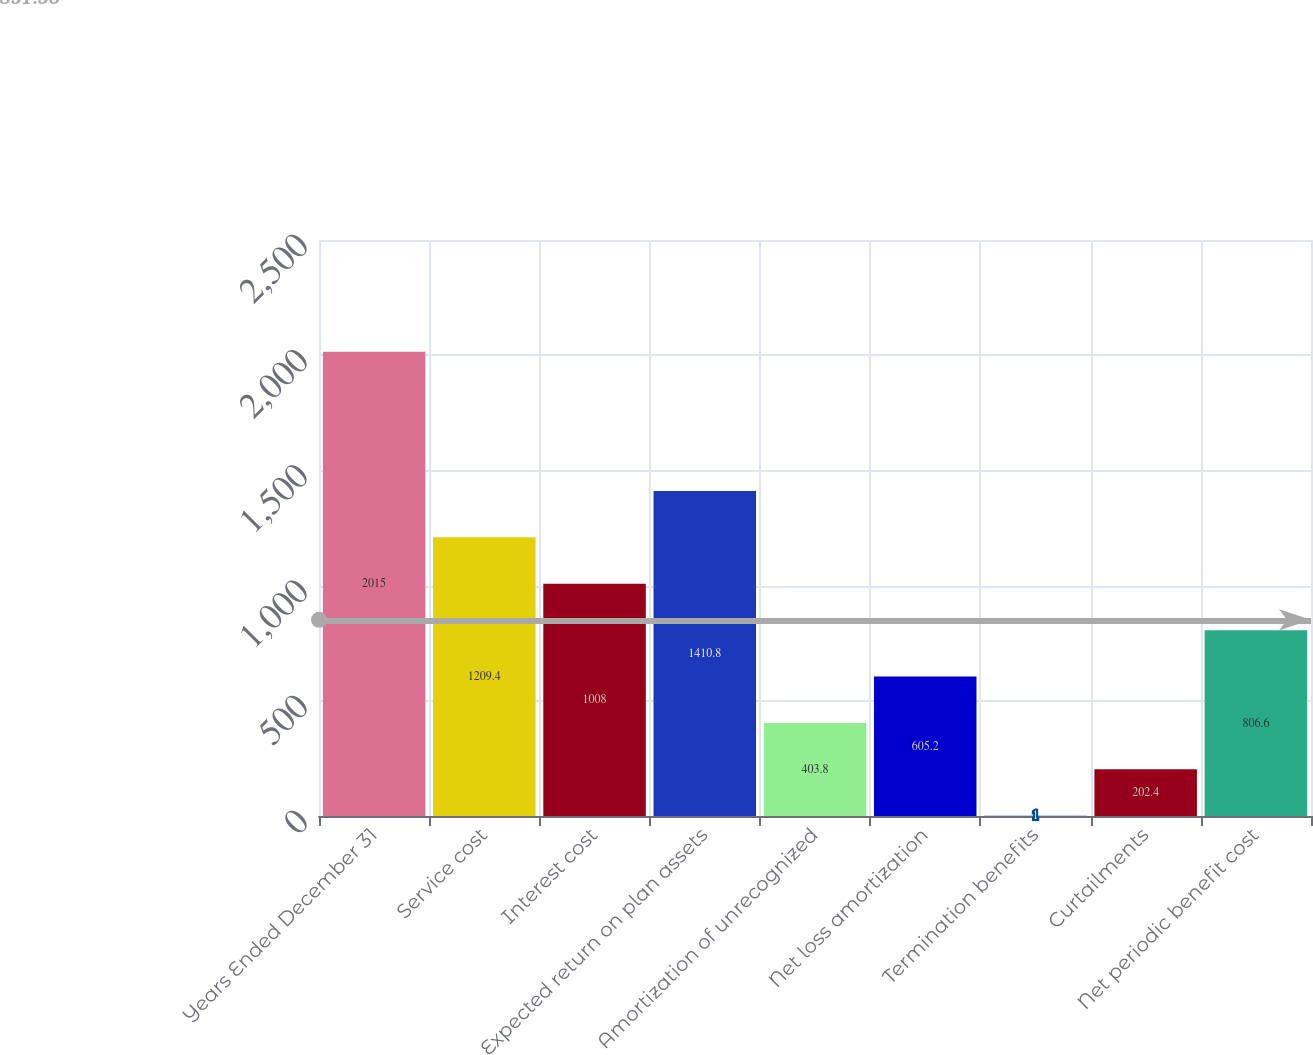Convert chart to OTSL. <chart><loc_0><loc_0><loc_500><loc_500><bar_chart><fcel>Years Ended December 31<fcel>Service cost<fcel>Interest cost<fcel>Expected return on plan assets<fcel>Amortization of unrecognized<fcel>Net loss amortization<fcel>Termination benefits<fcel>Curtailments<fcel>Net periodic benefit cost<nl><fcel>2015<fcel>1209.4<fcel>1008<fcel>1410.8<fcel>403.8<fcel>605.2<fcel>1<fcel>202.4<fcel>806.6<nl></chart> 